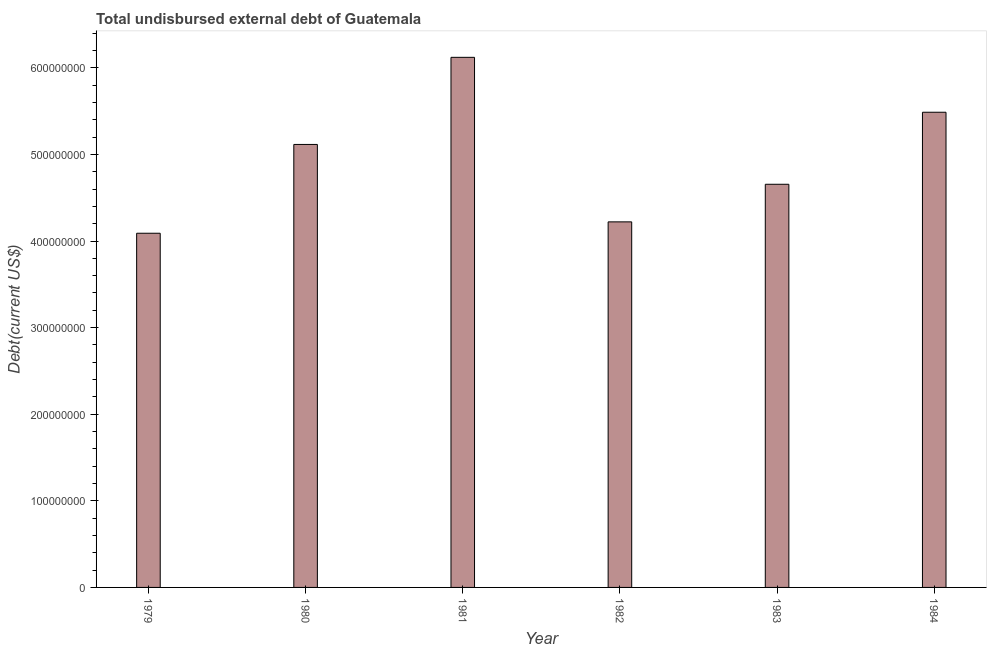Does the graph contain any zero values?
Your answer should be compact. No. What is the title of the graph?
Provide a short and direct response. Total undisbursed external debt of Guatemala. What is the label or title of the X-axis?
Offer a terse response. Year. What is the label or title of the Y-axis?
Provide a succinct answer. Debt(current US$). What is the total debt in 1979?
Make the answer very short. 4.09e+08. Across all years, what is the maximum total debt?
Give a very brief answer. 6.12e+08. Across all years, what is the minimum total debt?
Provide a short and direct response. 4.09e+08. In which year was the total debt minimum?
Your response must be concise. 1979. What is the sum of the total debt?
Make the answer very short. 2.97e+09. What is the difference between the total debt in 1980 and 1982?
Offer a very short reply. 8.94e+07. What is the average total debt per year?
Offer a terse response. 4.95e+08. What is the median total debt?
Provide a short and direct response. 4.89e+08. Do a majority of the years between 1984 and 1979 (inclusive) have total debt greater than 480000000 US$?
Your response must be concise. Yes. What is the difference between the highest and the second highest total debt?
Make the answer very short. 6.34e+07. Is the sum of the total debt in 1983 and 1984 greater than the maximum total debt across all years?
Make the answer very short. Yes. What is the difference between the highest and the lowest total debt?
Ensure brevity in your answer.  2.03e+08. How many bars are there?
Provide a short and direct response. 6. Are all the bars in the graph horizontal?
Keep it short and to the point. No. How many years are there in the graph?
Make the answer very short. 6. Are the values on the major ticks of Y-axis written in scientific E-notation?
Make the answer very short. No. What is the Debt(current US$) in 1979?
Offer a terse response. 4.09e+08. What is the Debt(current US$) in 1980?
Offer a very short reply. 5.12e+08. What is the Debt(current US$) in 1981?
Provide a short and direct response. 6.12e+08. What is the Debt(current US$) of 1982?
Provide a succinct answer. 4.22e+08. What is the Debt(current US$) of 1983?
Your answer should be very brief. 4.66e+08. What is the Debt(current US$) of 1984?
Offer a terse response. 5.49e+08. What is the difference between the Debt(current US$) in 1979 and 1980?
Your answer should be very brief. -1.03e+08. What is the difference between the Debt(current US$) in 1979 and 1981?
Your answer should be very brief. -2.03e+08. What is the difference between the Debt(current US$) in 1979 and 1982?
Offer a terse response. -1.31e+07. What is the difference between the Debt(current US$) in 1979 and 1983?
Your response must be concise. -5.65e+07. What is the difference between the Debt(current US$) in 1979 and 1984?
Keep it short and to the point. -1.40e+08. What is the difference between the Debt(current US$) in 1980 and 1981?
Ensure brevity in your answer.  -1.01e+08. What is the difference between the Debt(current US$) in 1980 and 1982?
Offer a very short reply. 8.94e+07. What is the difference between the Debt(current US$) in 1980 and 1983?
Provide a short and direct response. 4.60e+07. What is the difference between the Debt(current US$) in 1980 and 1984?
Offer a very short reply. -3.72e+07. What is the difference between the Debt(current US$) in 1981 and 1982?
Your answer should be compact. 1.90e+08. What is the difference between the Debt(current US$) in 1981 and 1983?
Provide a short and direct response. 1.47e+08. What is the difference between the Debt(current US$) in 1981 and 1984?
Ensure brevity in your answer.  6.34e+07. What is the difference between the Debt(current US$) in 1982 and 1983?
Keep it short and to the point. -4.34e+07. What is the difference between the Debt(current US$) in 1982 and 1984?
Make the answer very short. -1.27e+08. What is the difference between the Debt(current US$) in 1983 and 1984?
Make the answer very short. -8.32e+07. What is the ratio of the Debt(current US$) in 1979 to that in 1980?
Your response must be concise. 0.8. What is the ratio of the Debt(current US$) in 1979 to that in 1981?
Give a very brief answer. 0.67. What is the ratio of the Debt(current US$) in 1979 to that in 1982?
Your response must be concise. 0.97. What is the ratio of the Debt(current US$) in 1979 to that in 1983?
Ensure brevity in your answer.  0.88. What is the ratio of the Debt(current US$) in 1979 to that in 1984?
Offer a terse response. 0.74. What is the ratio of the Debt(current US$) in 1980 to that in 1981?
Offer a very short reply. 0.84. What is the ratio of the Debt(current US$) in 1980 to that in 1982?
Provide a short and direct response. 1.21. What is the ratio of the Debt(current US$) in 1980 to that in 1983?
Provide a short and direct response. 1.1. What is the ratio of the Debt(current US$) in 1980 to that in 1984?
Your answer should be very brief. 0.93. What is the ratio of the Debt(current US$) in 1981 to that in 1982?
Provide a short and direct response. 1.45. What is the ratio of the Debt(current US$) in 1981 to that in 1983?
Ensure brevity in your answer.  1.31. What is the ratio of the Debt(current US$) in 1981 to that in 1984?
Give a very brief answer. 1.12. What is the ratio of the Debt(current US$) in 1982 to that in 1983?
Your answer should be very brief. 0.91. What is the ratio of the Debt(current US$) in 1982 to that in 1984?
Keep it short and to the point. 0.77. What is the ratio of the Debt(current US$) in 1983 to that in 1984?
Keep it short and to the point. 0.85. 